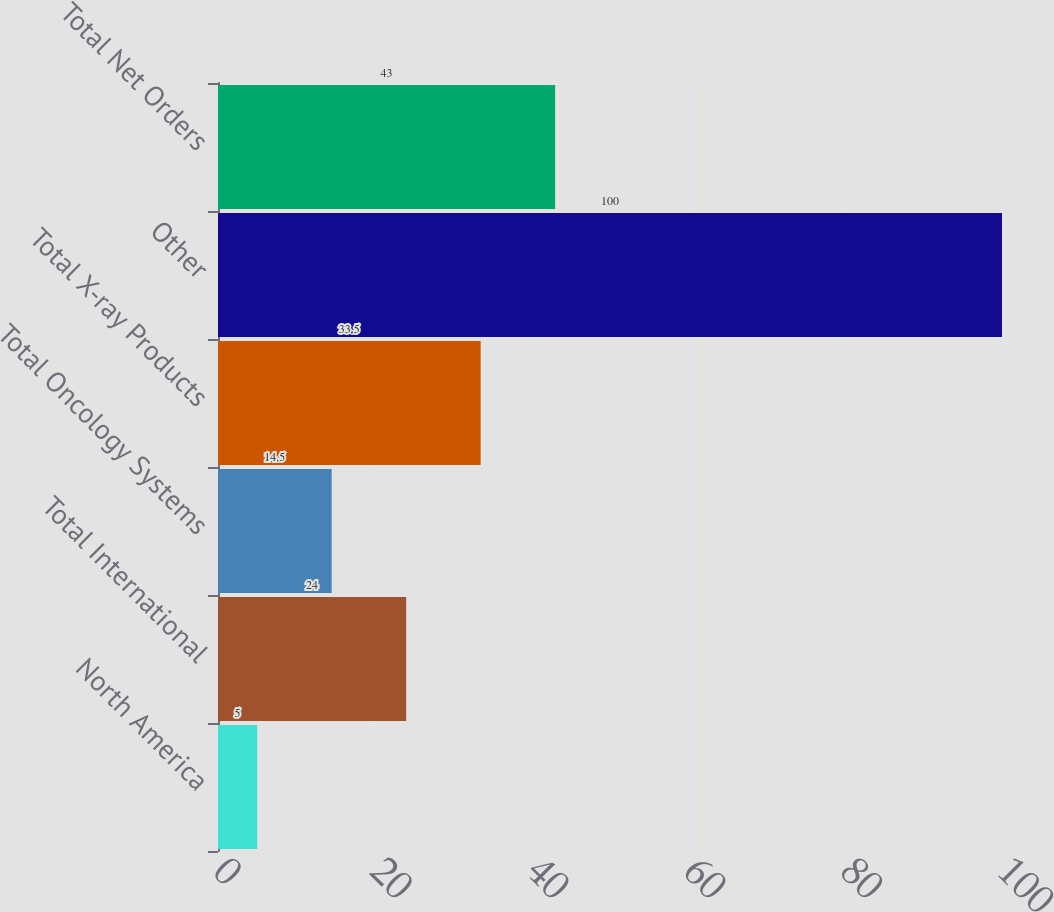<chart> <loc_0><loc_0><loc_500><loc_500><bar_chart><fcel>North America<fcel>Total International<fcel>Total Oncology Systems<fcel>Total X-ray Products<fcel>Other<fcel>Total Net Orders<nl><fcel>5<fcel>24<fcel>14.5<fcel>33.5<fcel>100<fcel>43<nl></chart> 